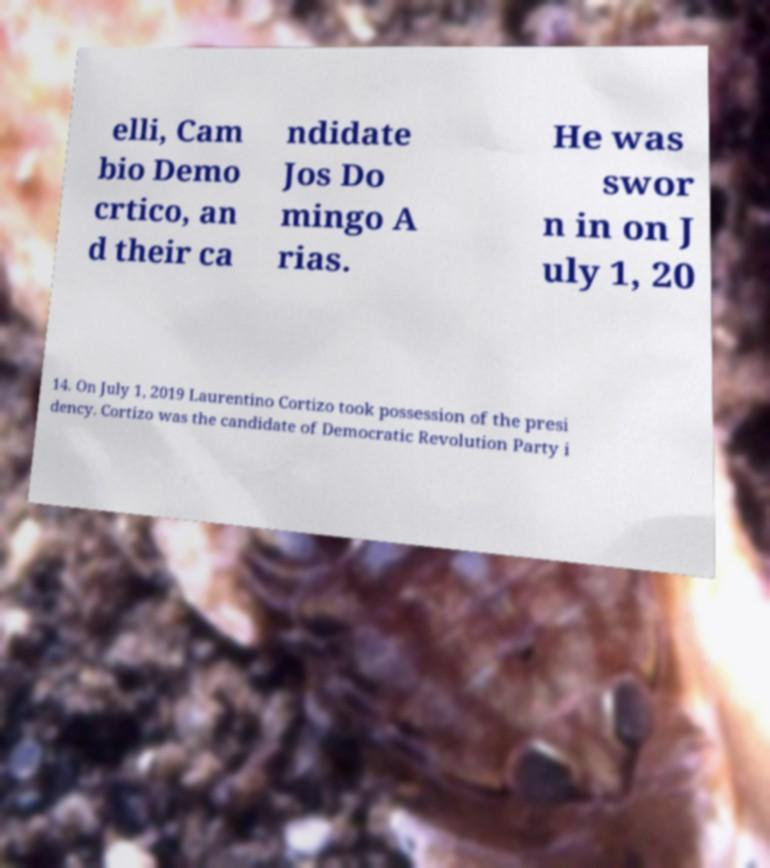What messages or text are displayed in this image? I need them in a readable, typed format. elli, Cam bio Demo crtico, an d their ca ndidate Jos Do mingo A rias. He was swor n in on J uly 1, 20 14. On July 1, 2019 Laurentino Cortizo took possession of the presi dency. Cortizo was the candidate of Democratic Revolution Party i 